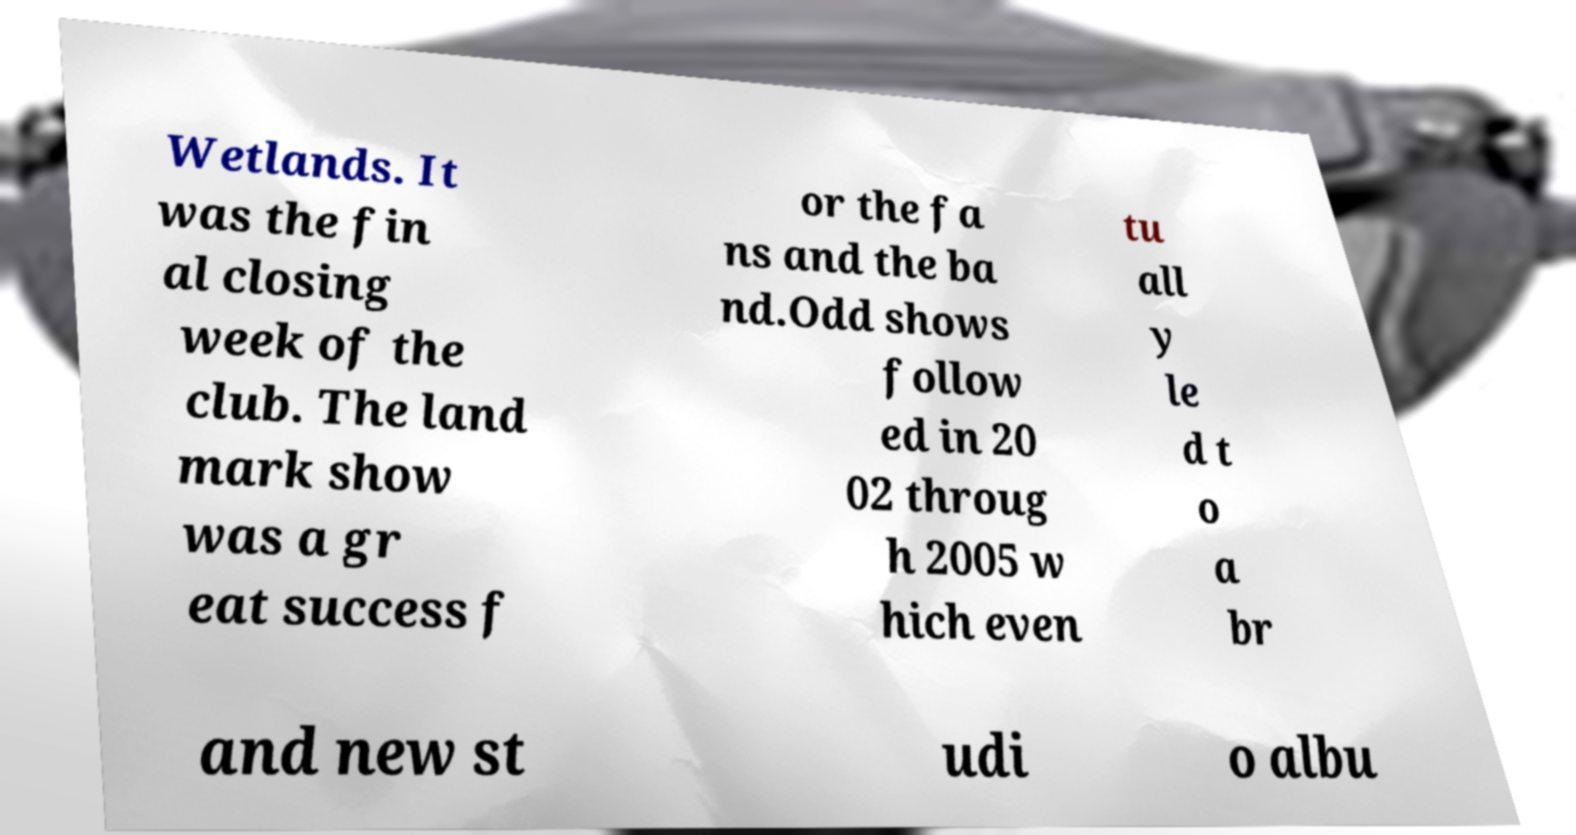What messages or text are displayed in this image? I need them in a readable, typed format. Wetlands. It was the fin al closing week of the club. The land mark show was a gr eat success f or the fa ns and the ba nd.Odd shows follow ed in 20 02 throug h 2005 w hich even tu all y le d t o a br and new st udi o albu 